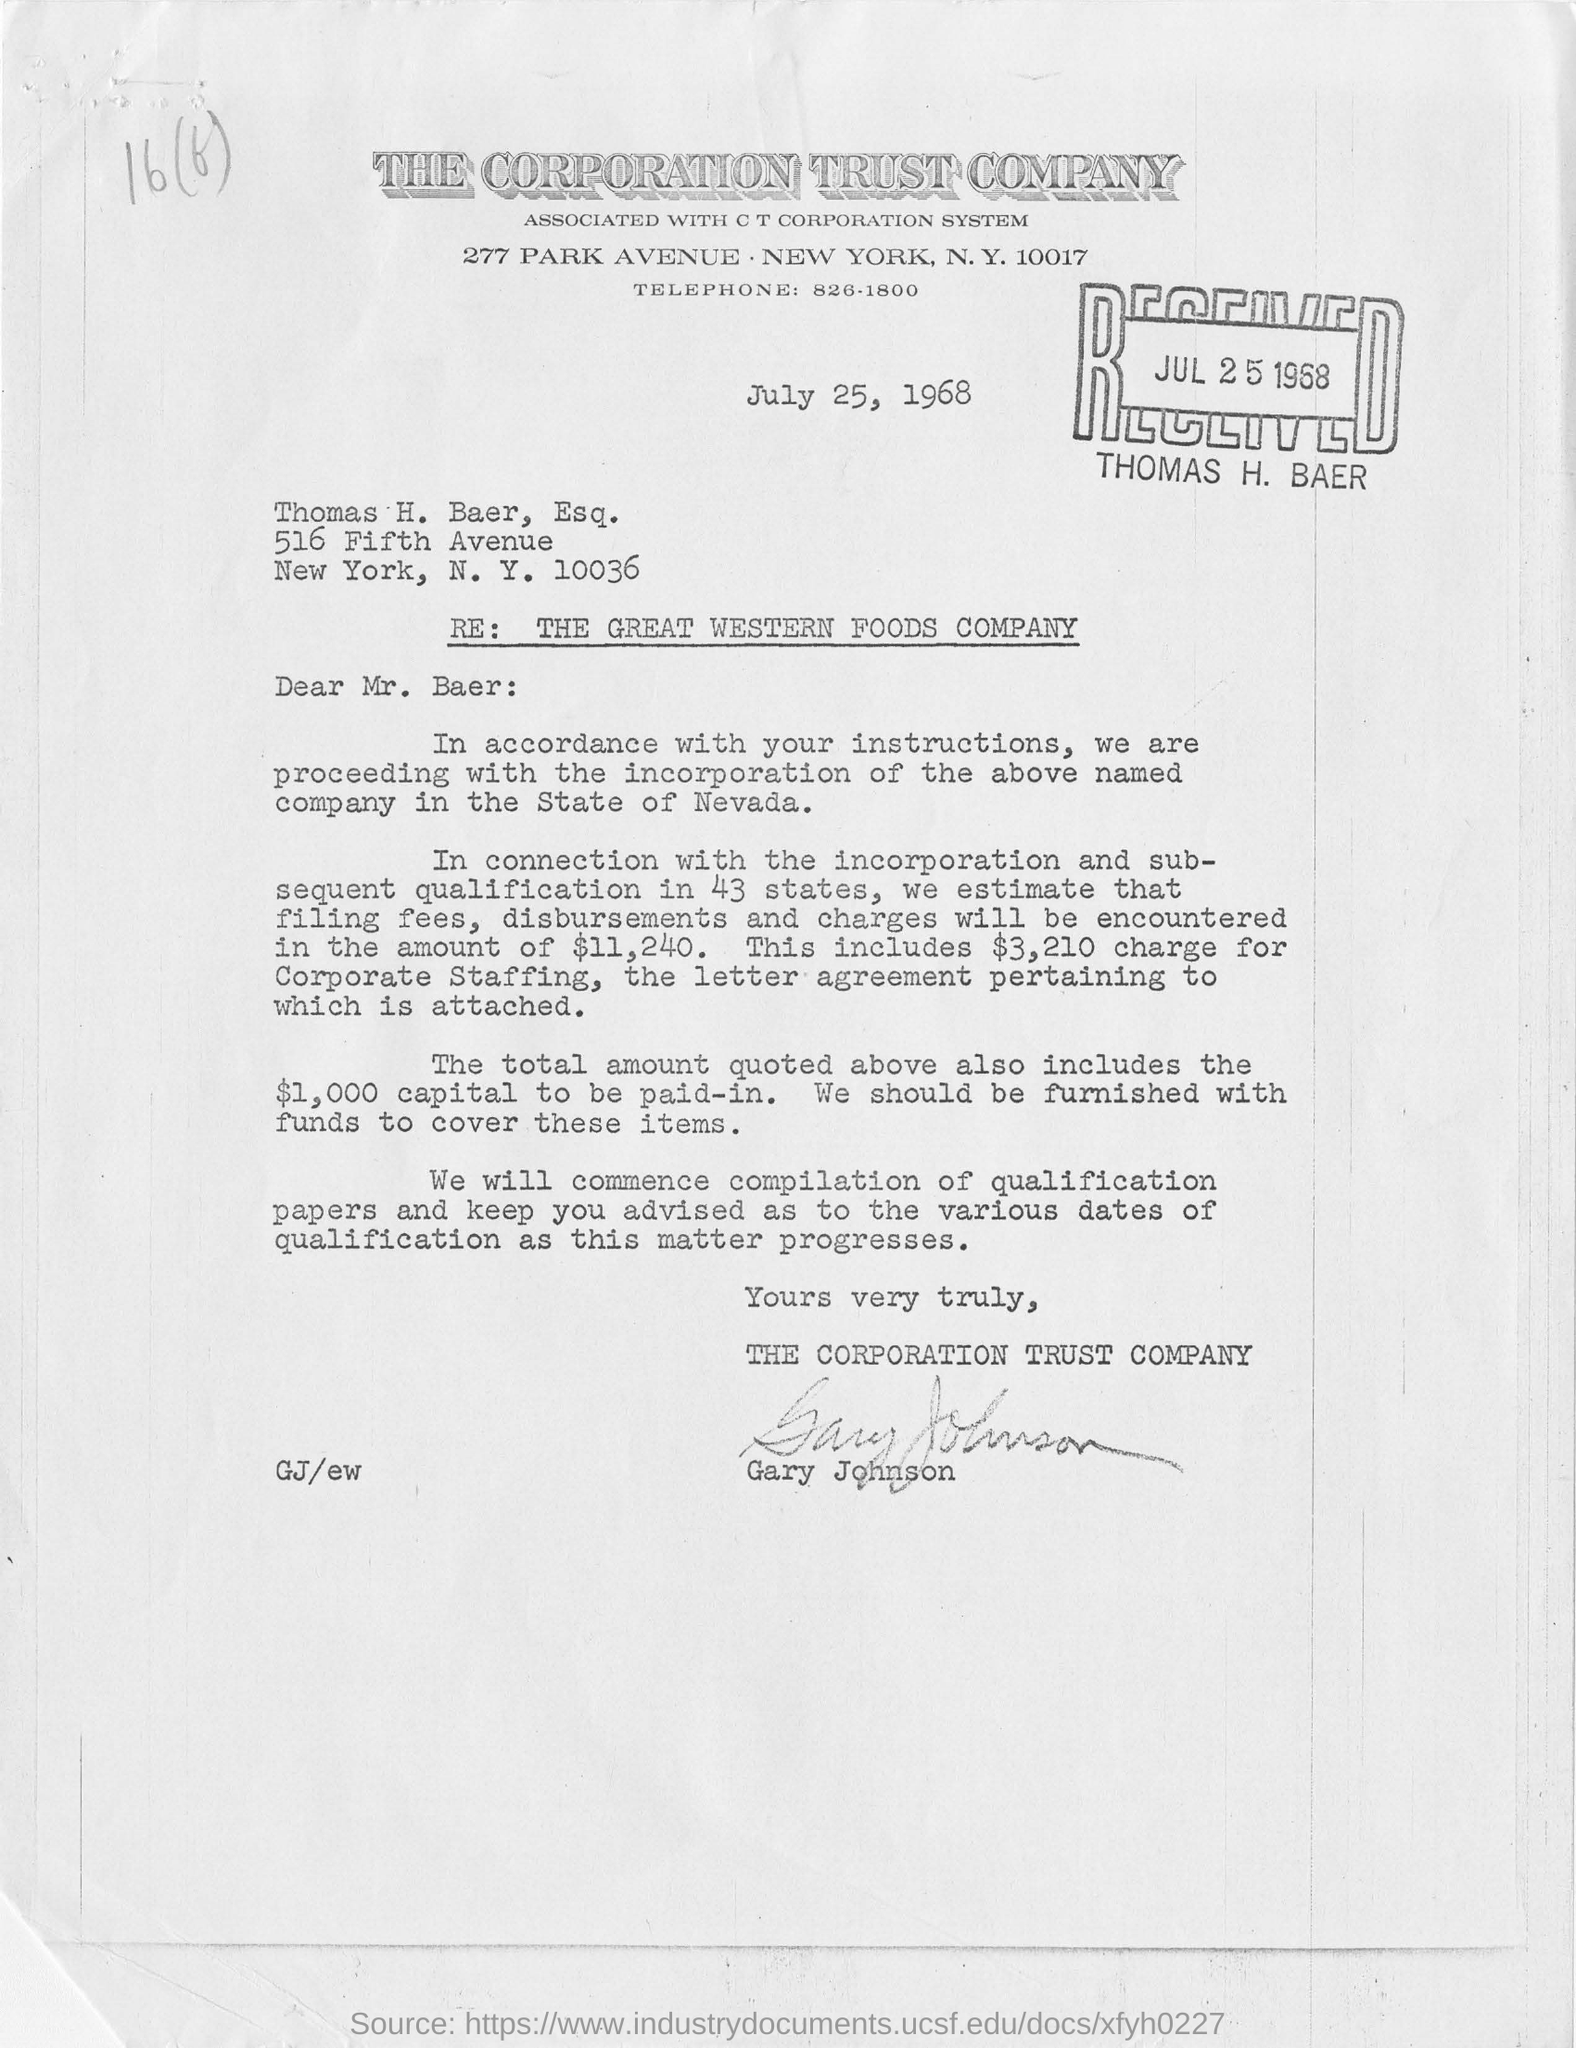Specify some key components in this picture. Thomas Baer received this letter on July 25, 1968. The stamp bears the name THOMAS H. BAER. The date mentioned in the document is July 25, 1968. The zip code mentioned at the top of the letterhead is 10017. 